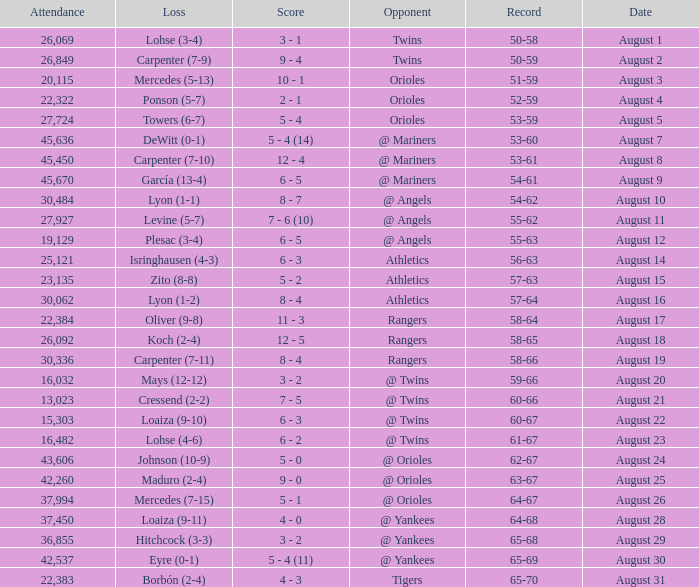What was the score of the game when their record was 62-67 5 - 0. 